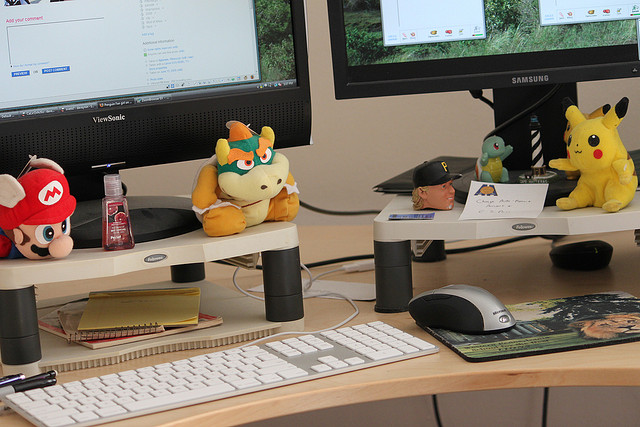Identify and read out the text in this image. M 